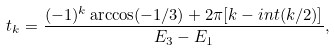<formula> <loc_0><loc_0><loc_500><loc_500>t _ { k } = \frac { ( - 1 ) ^ { k } \arccos ( - 1 / 3 ) + 2 \pi [ k - i n t ( k / 2 ) ] } { E _ { 3 } - E _ { 1 } } ,</formula> 